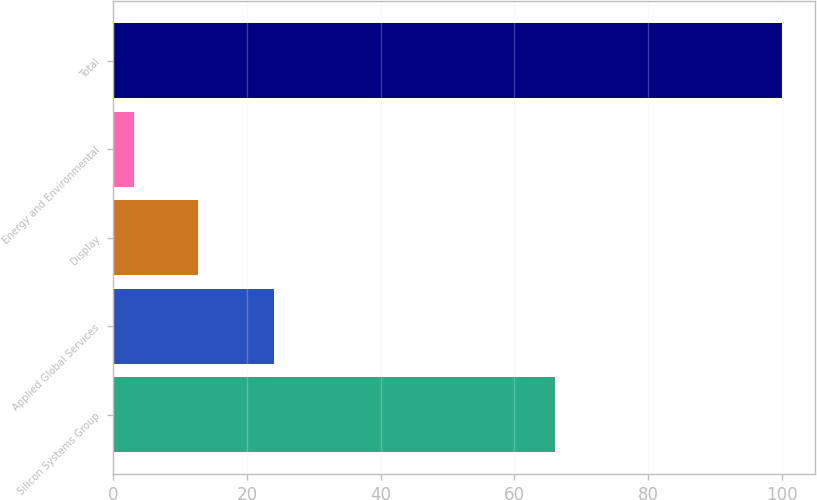Convert chart. <chart><loc_0><loc_0><loc_500><loc_500><bar_chart><fcel>Silicon Systems Group<fcel>Applied Global Services<fcel>Display<fcel>Energy and Environmental<fcel>Total<nl><fcel>66<fcel>24<fcel>12.7<fcel>3<fcel>100<nl></chart> 